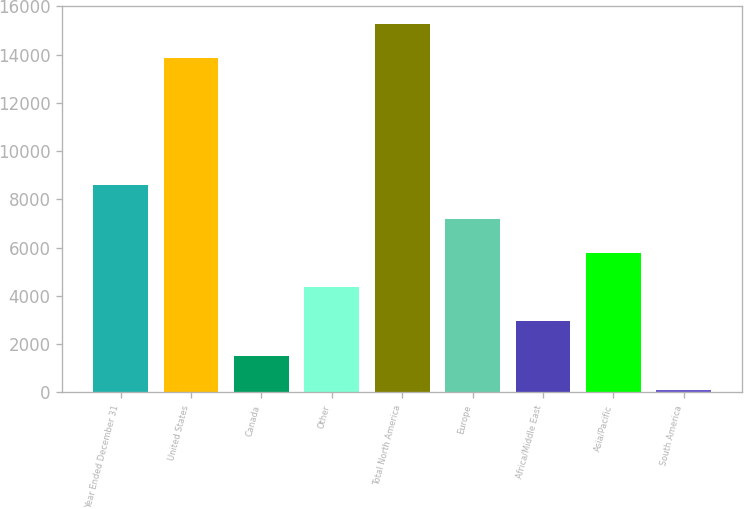Convert chart. <chart><loc_0><loc_0><loc_500><loc_500><bar_chart><fcel>Year Ended December 31<fcel>United States<fcel>Canada<fcel>Other<fcel>Total North America<fcel>Europe<fcel>Africa/Middle East<fcel>Asia/Pacific<fcel>South America<nl><fcel>8616.2<fcel>13850<fcel>1525.2<fcel>4361.6<fcel>15268.2<fcel>7198<fcel>2943.4<fcel>5779.8<fcel>107<nl></chart> 